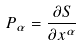<formula> <loc_0><loc_0><loc_500><loc_500>P _ { \alpha } = \frac { \partial S } { \partial x ^ { \alpha } }</formula> 